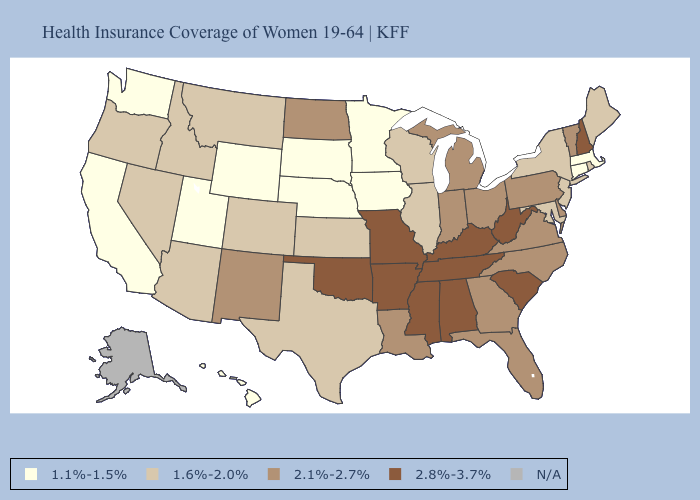Does Wisconsin have the lowest value in the USA?
Keep it brief. No. Name the states that have a value in the range N/A?
Concise answer only. Alaska. Which states hav the highest value in the MidWest?
Concise answer only. Missouri. What is the lowest value in the South?
Be succinct. 1.6%-2.0%. How many symbols are there in the legend?
Concise answer only. 5. What is the value of Nebraska?
Be succinct. 1.1%-1.5%. What is the lowest value in states that border Mississippi?
Answer briefly. 2.1%-2.7%. What is the lowest value in the West?
Be succinct. 1.1%-1.5%. Does Louisiana have the highest value in the South?
Concise answer only. No. What is the highest value in the Northeast ?
Answer briefly. 2.8%-3.7%. What is the value of Pennsylvania?
Quick response, please. 2.1%-2.7%. What is the value of Kansas?
Quick response, please. 1.6%-2.0%. 